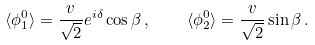<formula> <loc_0><loc_0><loc_500><loc_500>\langle \phi _ { 1 } ^ { 0 } \rangle = \frac { v } { \sqrt { 2 } } e ^ { i \delta } \cos \beta \, , \quad \langle \phi _ { 2 } ^ { 0 } \rangle = \frac { v } { \sqrt { 2 } } \sin \beta \, .</formula> 